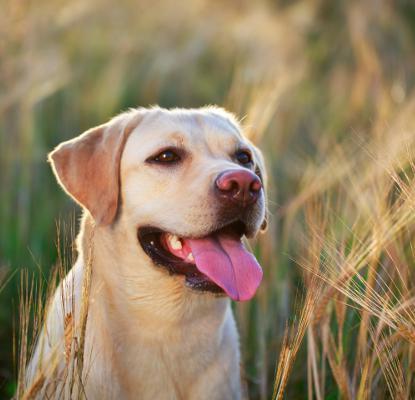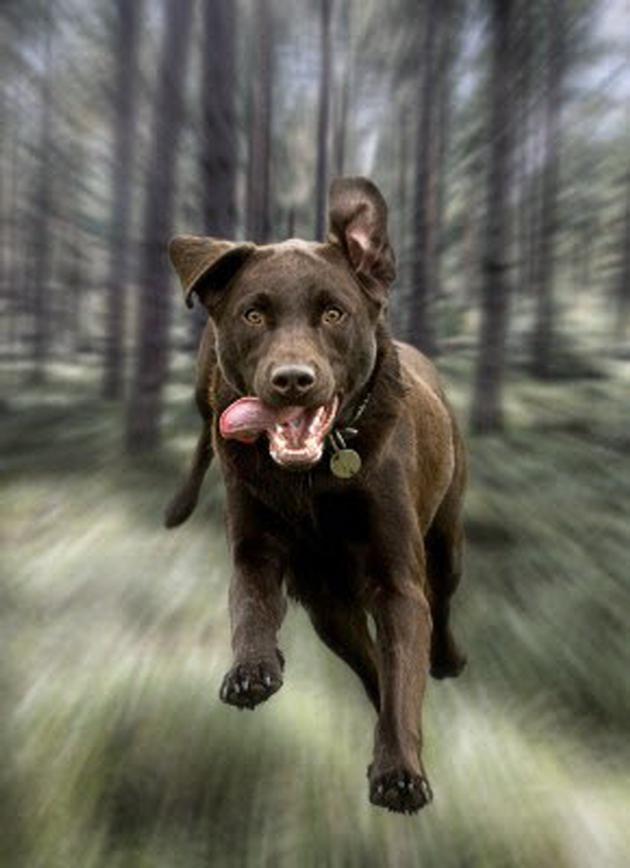The first image is the image on the left, the second image is the image on the right. Assess this claim about the two images: "There is no more than four dogs.". Correct or not? Answer yes or no. Yes. 